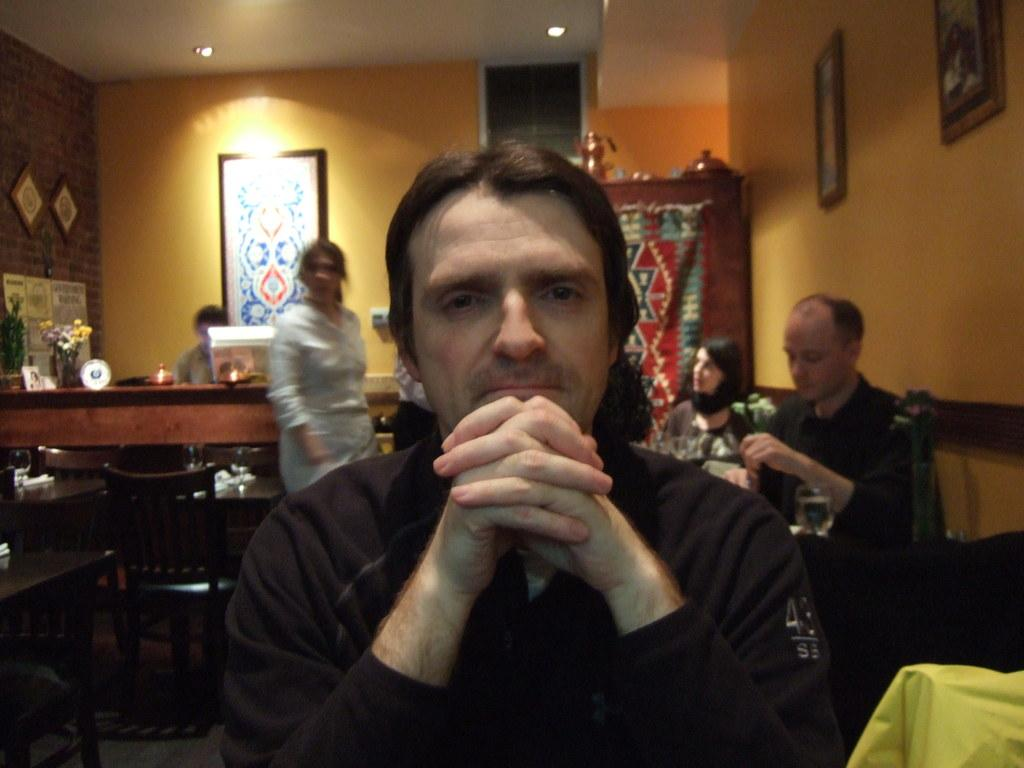What are the people in the image doing? There is a group of people seated on chairs in the image. Can you describe the woman in the image? There is a woman standing in the image. What can be seen on the wall in the image? There is a photo frame on the wall in the image. What is visible in the image that provides illumination? There are lights visible in the image. What type of suit is the woman wearing in the image? There is no suit visible in the image; the woman is not wearing one. What type of polish is being applied to the self in the image? There is no self or polish application present in the image. 